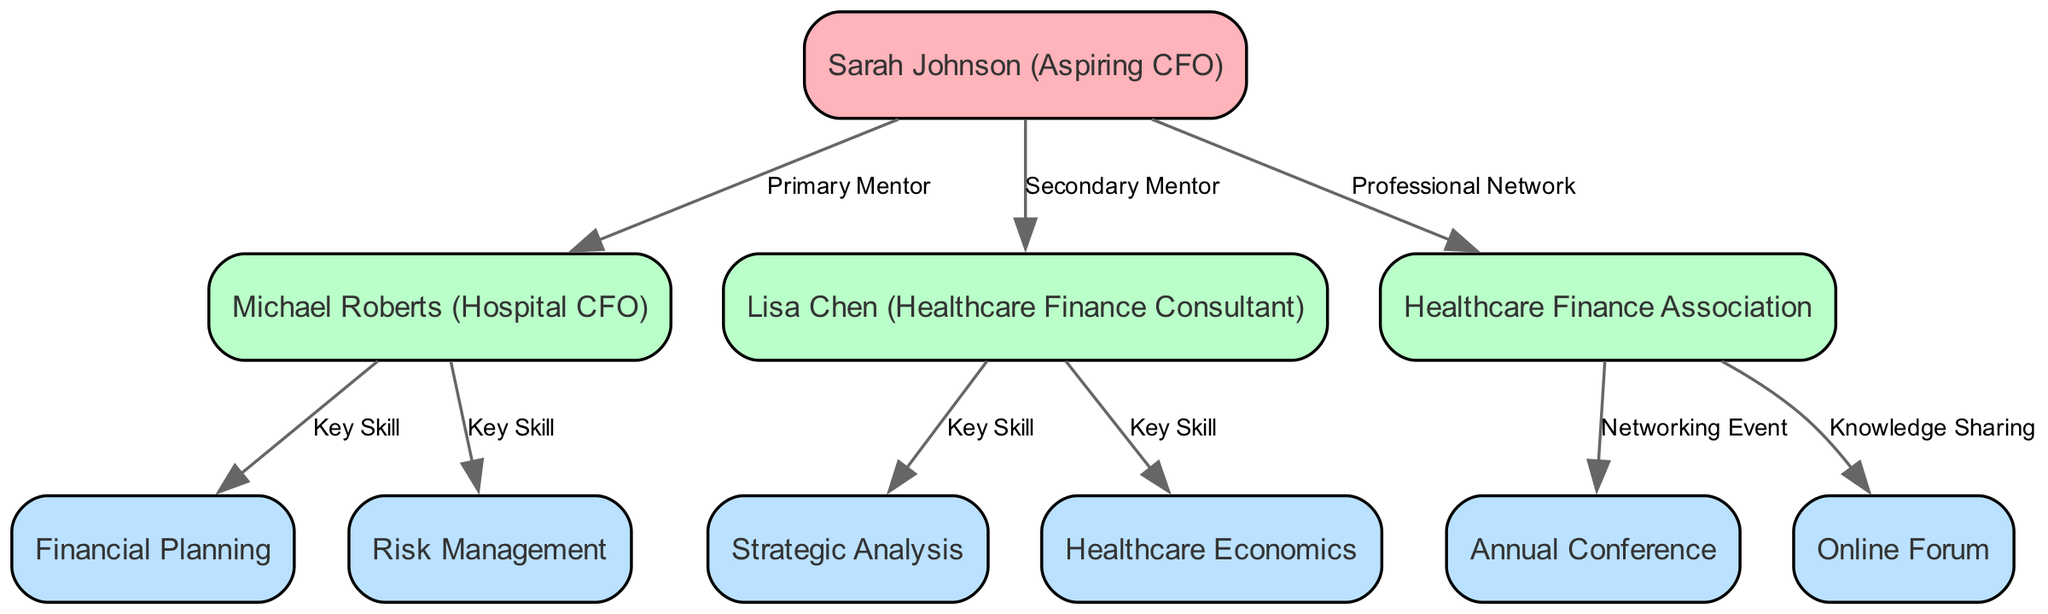What is the name of the root node? The root node in the diagram represents the individual seeking mentorship. According to the data provided, this node is called "Sarah Johnson (Aspiring CFO)".
Answer: Sarah Johnson (Aspiring CFO) Who is the primary mentor? The primary mentor node directly connected to the root node indicates the most significant mentor relationship. Based on the data, this mentor is "Michael Roberts (Hospital CFO)".
Answer: Michael Roberts (Hospital CFO) How many key skills are associated with Michael Roberts? The node under "Michael Roberts (Hospital CFO)" lists his children's nodes, which represent key skills. There are two children listed: "Financial Planning" and "Risk Management", indicating two key skills.
Answer: 2 Which relationship connects "Lisa Chen (Healthcare Finance Consultant)" to "Sarah Johnson (Aspiring CFO)"? The diagram illustrates the connection using relational descriptions. The relationship specified between "Lisa Chen (Healthcare Finance Consultant)" and "Sarah Johnson (Aspiring CFO)" is labeled as "Secondary Mentor".
Answer: Secondary Mentor What networking event is associated with the "Healthcare Finance Association"? The children of the node "Healthcare Finance Association" detail various opportunities. Among them is "Annual Conference", which is labeled as a networking event.
Answer: Annual Conference Which key skill relates to Lisa Chen? Within the node of "Lisa Chen (Healthcare Finance Consultant)", there are two skills listed. The first is "Strategic Analysis", which specifically names one of her key skills.
Answer: Strategic Analysis How many nodes represent key skills in total? To determine the total number of nodes representing key skills, we tally up each key skill from the mentors. Michael Roberts has two (Financial Planning and Risk Management), and Lisa Chen has two (Strategic Analysis and Healthcare Economics). Summing these results gives a total of four key skills.
Answer: 4 What type of node is "Healthcare Finance Association"? The description attached to "Healthcare Finance Association" explains its role within the diagram. It is labeled as a "Professional Network", indicating its purpose and relationship to the other nodes.
Answer: Professional Network Which key skill is linked to "Healthcare Economics"? Analyzing the node under "Lisa Chen (Healthcare Finance Consultant)", "Healthcare Economics" is distinctly noted as a key skill, thus establishing its connection to her mentorship role.
Answer: Healthcare Economics 